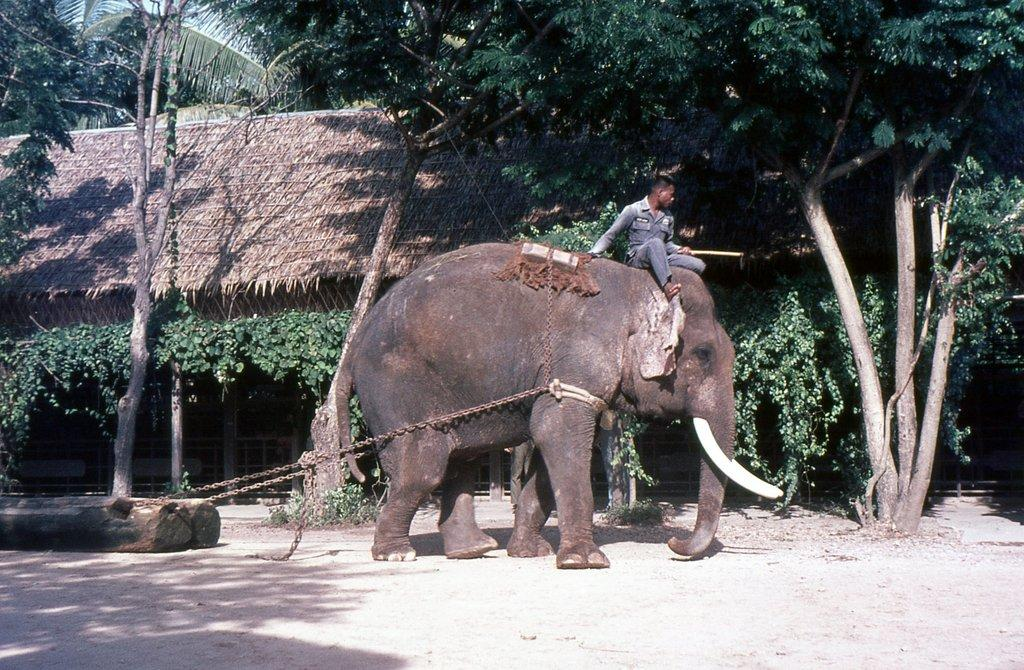What animal is present in the image? There is an elephant in the image. Who is on the elephant? A man is sitting on the elephant. What can be seen in the background of the image? There are green color trees in the background of the image. How many babies are crawling on the ground in the image? There are no babies present in the image. What type of wood is the elephant made of in the image? The image is a photograph, and the elephant is a real animal, not made of wood. 